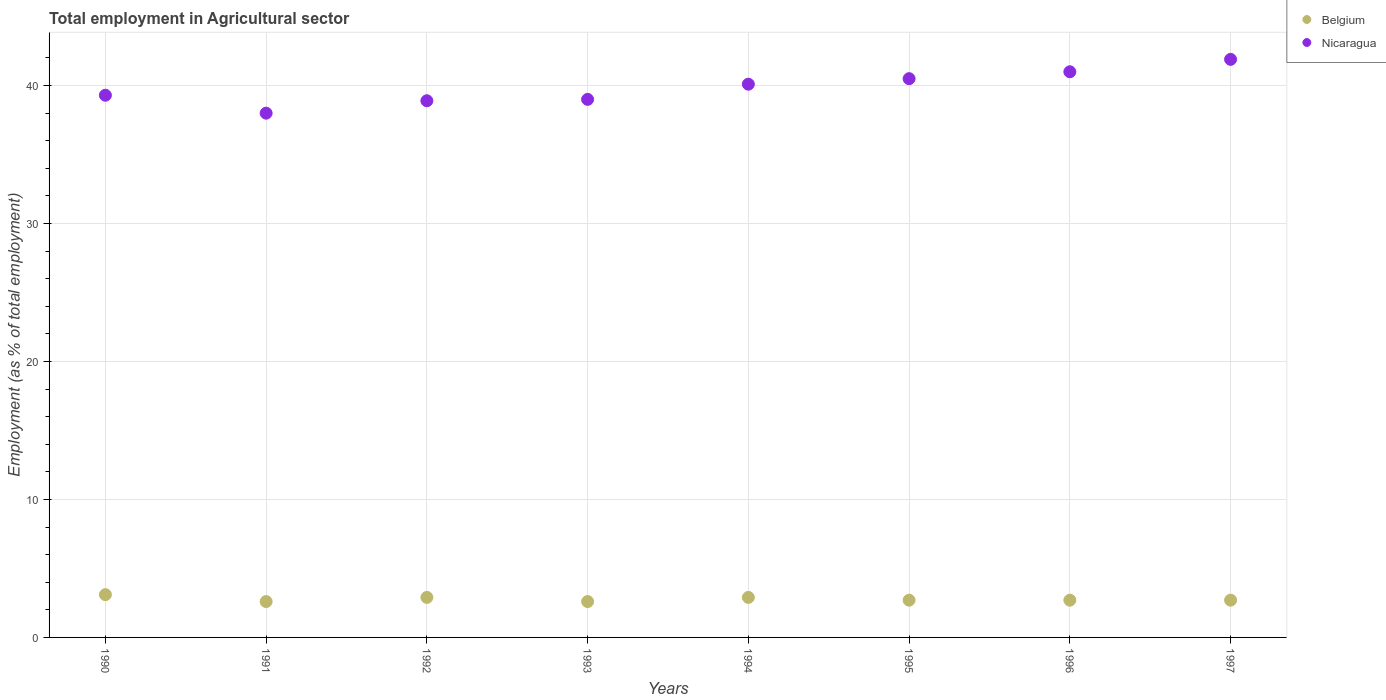How many different coloured dotlines are there?
Offer a terse response. 2. What is the employment in agricultural sector in Nicaragua in 1991?
Offer a very short reply. 38. Across all years, what is the maximum employment in agricultural sector in Nicaragua?
Offer a terse response. 41.9. Across all years, what is the minimum employment in agricultural sector in Belgium?
Ensure brevity in your answer.  2.6. What is the total employment in agricultural sector in Nicaragua in the graph?
Offer a very short reply. 318.7. What is the difference between the employment in agricultural sector in Nicaragua in 1990 and that in 1997?
Provide a short and direct response. -2.6. What is the difference between the employment in agricultural sector in Belgium in 1991 and the employment in agricultural sector in Nicaragua in 1995?
Provide a short and direct response. -37.9. What is the average employment in agricultural sector in Nicaragua per year?
Give a very brief answer. 39.84. In the year 1995, what is the difference between the employment in agricultural sector in Nicaragua and employment in agricultural sector in Belgium?
Make the answer very short. 37.8. In how many years, is the employment in agricultural sector in Nicaragua greater than 24 %?
Your response must be concise. 8. What is the difference between the highest and the second highest employment in agricultural sector in Nicaragua?
Offer a terse response. 0.9. What is the difference between the highest and the lowest employment in agricultural sector in Nicaragua?
Your answer should be compact. 3.9. In how many years, is the employment in agricultural sector in Belgium greater than the average employment in agricultural sector in Belgium taken over all years?
Your answer should be very brief. 3. Does the employment in agricultural sector in Belgium monotonically increase over the years?
Make the answer very short. No. Is the employment in agricultural sector in Belgium strictly less than the employment in agricultural sector in Nicaragua over the years?
Your answer should be very brief. Yes. How many years are there in the graph?
Provide a succinct answer. 8. What is the difference between two consecutive major ticks on the Y-axis?
Keep it short and to the point. 10. Where does the legend appear in the graph?
Offer a terse response. Top right. How many legend labels are there?
Your response must be concise. 2. How are the legend labels stacked?
Make the answer very short. Vertical. What is the title of the graph?
Keep it short and to the point. Total employment in Agricultural sector. Does "East Asia (all income levels)" appear as one of the legend labels in the graph?
Ensure brevity in your answer.  No. What is the label or title of the X-axis?
Provide a succinct answer. Years. What is the label or title of the Y-axis?
Make the answer very short. Employment (as % of total employment). What is the Employment (as % of total employment) in Belgium in 1990?
Offer a terse response. 3.1. What is the Employment (as % of total employment) in Nicaragua in 1990?
Your answer should be compact. 39.3. What is the Employment (as % of total employment) of Belgium in 1991?
Give a very brief answer. 2.6. What is the Employment (as % of total employment) of Belgium in 1992?
Offer a terse response. 2.9. What is the Employment (as % of total employment) in Nicaragua in 1992?
Give a very brief answer. 38.9. What is the Employment (as % of total employment) of Belgium in 1993?
Offer a terse response. 2.6. What is the Employment (as % of total employment) of Nicaragua in 1993?
Your answer should be very brief. 39. What is the Employment (as % of total employment) in Belgium in 1994?
Your answer should be compact. 2.9. What is the Employment (as % of total employment) of Nicaragua in 1994?
Offer a very short reply. 40.1. What is the Employment (as % of total employment) of Belgium in 1995?
Your answer should be very brief. 2.7. What is the Employment (as % of total employment) in Nicaragua in 1995?
Your answer should be very brief. 40.5. What is the Employment (as % of total employment) of Belgium in 1996?
Ensure brevity in your answer.  2.7. What is the Employment (as % of total employment) of Nicaragua in 1996?
Your answer should be compact. 41. What is the Employment (as % of total employment) of Belgium in 1997?
Make the answer very short. 2.7. What is the Employment (as % of total employment) of Nicaragua in 1997?
Offer a terse response. 41.9. Across all years, what is the maximum Employment (as % of total employment) in Belgium?
Provide a succinct answer. 3.1. Across all years, what is the maximum Employment (as % of total employment) of Nicaragua?
Provide a succinct answer. 41.9. Across all years, what is the minimum Employment (as % of total employment) in Belgium?
Keep it short and to the point. 2.6. Across all years, what is the minimum Employment (as % of total employment) in Nicaragua?
Give a very brief answer. 38. What is the total Employment (as % of total employment) in Belgium in the graph?
Offer a very short reply. 22.2. What is the total Employment (as % of total employment) in Nicaragua in the graph?
Make the answer very short. 318.7. What is the difference between the Employment (as % of total employment) of Belgium in 1990 and that in 1991?
Your response must be concise. 0.5. What is the difference between the Employment (as % of total employment) in Nicaragua in 1990 and that in 1992?
Your answer should be very brief. 0.4. What is the difference between the Employment (as % of total employment) of Belgium in 1990 and that in 1993?
Ensure brevity in your answer.  0.5. What is the difference between the Employment (as % of total employment) of Belgium in 1990 and that in 1996?
Your answer should be very brief. 0.4. What is the difference between the Employment (as % of total employment) of Belgium in 1990 and that in 1997?
Your response must be concise. 0.4. What is the difference between the Employment (as % of total employment) in Nicaragua in 1990 and that in 1997?
Offer a terse response. -2.6. What is the difference between the Employment (as % of total employment) of Belgium in 1991 and that in 1993?
Provide a short and direct response. 0. What is the difference between the Employment (as % of total employment) of Nicaragua in 1991 and that in 1993?
Your answer should be very brief. -1. What is the difference between the Employment (as % of total employment) of Belgium in 1991 and that in 1995?
Make the answer very short. -0.1. What is the difference between the Employment (as % of total employment) of Nicaragua in 1991 and that in 1995?
Your answer should be very brief. -2.5. What is the difference between the Employment (as % of total employment) in Belgium in 1991 and that in 1997?
Your answer should be compact. -0.1. What is the difference between the Employment (as % of total employment) of Nicaragua in 1992 and that in 1993?
Make the answer very short. -0.1. What is the difference between the Employment (as % of total employment) in Nicaragua in 1992 and that in 1994?
Provide a succinct answer. -1.2. What is the difference between the Employment (as % of total employment) in Belgium in 1992 and that in 1995?
Offer a very short reply. 0.2. What is the difference between the Employment (as % of total employment) in Nicaragua in 1992 and that in 1995?
Offer a terse response. -1.6. What is the difference between the Employment (as % of total employment) in Nicaragua in 1992 and that in 1997?
Offer a terse response. -3. What is the difference between the Employment (as % of total employment) of Nicaragua in 1993 and that in 1994?
Offer a very short reply. -1.1. What is the difference between the Employment (as % of total employment) in Nicaragua in 1993 and that in 1995?
Provide a short and direct response. -1.5. What is the difference between the Employment (as % of total employment) in Belgium in 1993 and that in 1996?
Ensure brevity in your answer.  -0.1. What is the difference between the Employment (as % of total employment) of Nicaragua in 1993 and that in 1996?
Make the answer very short. -2. What is the difference between the Employment (as % of total employment) of Belgium in 1993 and that in 1997?
Your response must be concise. -0.1. What is the difference between the Employment (as % of total employment) in Nicaragua in 1993 and that in 1997?
Ensure brevity in your answer.  -2.9. What is the difference between the Employment (as % of total employment) of Nicaragua in 1994 and that in 1996?
Ensure brevity in your answer.  -0.9. What is the difference between the Employment (as % of total employment) in Nicaragua in 1994 and that in 1997?
Make the answer very short. -1.8. What is the difference between the Employment (as % of total employment) in Nicaragua in 1995 and that in 1996?
Your answer should be very brief. -0.5. What is the difference between the Employment (as % of total employment) in Belgium in 1995 and that in 1997?
Provide a short and direct response. 0. What is the difference between the Employment (as % of total employment) of Nicaragua in 1995 and that in 1997?
Offer a very short reply. -1.4. What is the difference between the Employment (as % of total employment) of Belgium in 1990 and the Employment (as % of total employment) of Nicaragua in 1991?
Provide a short and direct response. -34.9. What is the difference between the Employment (as % of total employment) in Belgium in 1990 and the Employment (as % of total employment) in Nicaragua in 1992?
Your answer should be compact. -35.8. What is the difference between the Employment (as % of total employment) of Belgium in 1990 and the Employment (as % of total employment) of Nicaragua in 1993?
Offer a terse response. -35.9. What is the difference between the Employment (as % of total employment) in Belgium in 1990 and the Employment (as % of total employment) in Nicaragua in 1994?
Your response must be concise. -37. What is the difference between the Employment (as % of total employment) of Belgium in 1990 and the Employment (as % of total employment) of Nicaragua in 1995?
Ensure brevity in your answer.  -37.4. What is the difference between the Employment (as % of total employment) in Belgium in 1990 and the Employment (as % of total employment) in Nicaragua in 1996?
Your answer should be compact. -37.9. What is the difference between the Employment (as % of total employment) of Belgium in 1990 and the Employment (as % of total employment) of Nicaragua in 1997?
Provide a succinct answer. -38.8. What is the difference between the Employment (as % of total employment) of Belgium in 1991 and the Employment (as % of total employment) of Nicaragua in 1992?
Make the answer very short. -36.3. What is the difference between the Employment (as % of total employment) of Belgium in 1991 and the Employment (as % of total employment) of Nicaragua in 1993?
Provide a short and direct response. -36.4. What is the difference between the Employment (as % of total employment) of Belgium in 1991 and the Employment (as % of total employment) of Nicaragua in 1994?
Your response must be concise. -37.5. What is the difference between the Employment (as % of total employment) of Belgium in 1991 and the Employment (as % of total employment) of Nicaragua in 1995?
Offer a very short reply. -37.9. What is the difference between the Employment (as % of total employment) in Belgium in 1991 and the Employment (as % of total employment) in Nicaragua in 1996?
Your response must be concise. -38.4. What is the difference between the Employment (as % of total employment) of Belgium in 1991 and the Employment (as % of total employment) of Nicaragua in 1997?
Your answer should be compact. -39.3. What is the difference between the Employment (as % of total employment) of Belgium in 1992 and the Employment (as % of total employment) of Nicaragua in 1993?
Provide a short and direct response. -36.1. What is the difference between the Employment (as % of total employment) of Belgium in 1992 and the Employment (as % of total employment) of Nicaragua in 1994?
Give a very brief answer. -37.2. What is the difference between the Employment (as % of total employment) in Belgium in 1992 and the Employment (as % of total employment) in Nicaragua in 1995?
Your answer should be very brief. -37.6. What is the difference between the Employment (as % of total employment) in Belgium in 1992 and the Employment (as % of total employment) in Nicaragua in 1996?
Provide a short and direct response. -38.1. What is the difference between the Employment (as % of total employment) of Belgium in 1992 and the Employment (as % of total employment) of Nicaragua in 1997?
Your response must be concise. -39. What is the difference between the Employment (as % of total employment) in Belgium in 1993 and the Employment (as % of total employment) in Nicaragua in 1994?
Ensure brevity in your answer.  -37.5. What is the difference between the Employment (as % of total employment) of Belgium in 1993 and the Employment (as % of total employment) of Nicaragua in 1995?
Your answer should be compact. -37.9. What is the difference between the Employment (as % of total employment) of Belgium in 1993 and the Employment (as % of total employment) of Nicaragua in 1996?
Offer a very short reply. -38.4. What is the difference between the Employment (as % of total employment) of Belgium in 1993 and the Employment (as % of total employment) of Nicaragua in 1997?
Give a very brief answer. -39.3. What is the difference between the Employment (as % of total employment) in Belgium in 1994 and the Employment (as % of total employment) in Nicaragua in 1995?
Your answer should be compact. -37.6. What is the difference between the Employment (as % of total employment) in Belgium in 1994 and the Employment (as % of total employment) in Nicaragua in 1996?
Offer a terse response. -38.1. What is the difference between the Employment (as % of total employment) of Belgium in 1994 and the Employment (as % of total employment) of Nicaragua in 1997?
Provide a succinct answer. -39. What is the difference between the Employment (as % of total employment) in Belgium in 1995 and the Employment (as % of total employment) in Nicaragua in 1996?
Your response must be concise. -38.3. What is the difference between the Employment (as % of total employment) of Belgium in 1995 and the Employment (as % of total employment) of Nicaragua in 1997?
Provide a succinct answer. -39.2. What is the difference between the Employment (as % of total employment) in Belgium in 1996 and the Employment (as % of total employment) in Nicaragua in 1997?
Your answer should be compact. -39.2. What is the average Employment (as % of total employment) in Belgium per year?
Provide a succinct answer. 2.77. What is the average Employment (as % of total employment) of Nicaragua per year?
Offer a terse response. 39.84. In the year 1990, what is the difference between the Employment (as % of total employment) of Belgium and Employment (as % of total employment) of Nicaragua?
Offer a terse response. -36.2. In the year 1991, what is the difference between the Employment (as % of total employment) of Belgium and Employment (as % of total employment) of Nicaragua?
Provide a short and direct response. -35.4. In the year 1992, what is the difference between the Employment (as % of total employment) of Belgium and Employment (as % of total employment) of Nicaragua?
Give a very brief answer. -36. In the year 1993, what is the difference between the Employment (as % of total employment) of Belgium and Employment (as % of total employment) of Nicaragua?
Ensure brevity in your answer.  -36.4. In the year 1994, what is the difference between the Employment (as % of total employment) in Belgium and Employment (as % of total employment) in Nicaragua?
Provide a succinct answer. -37.2. In the year 1995, what is the difference between the Employment (as % of total employment) of Belgium and Employment (as % of total employment) of Nicaragua?
Your answer should be very brief. -37.8. In the year 1996, what is the difference between the Employment (as % of total employment) in Belgium and Employment (as % of total employment) in Nicaragua?
Your answer should be very brief. -38.3. In the year 1997, what is the difference between the Employment (as % of total employment) in Belgium and Employment (as % of total employment) in Nicaragua?
Your response must be concise. -39.2. What is the ratio of the Employment (as % of total employment) of Belgium in 1990 to that in 1991?
Keep it short and to the point. 1.19. What is the ratio of the Employment (as % of total employment) of Nicaragua in 1990 to that in 1991?
Offer a terse response. 1.03. What is the ratio of the Employment (as % of total employment) of Belgium in 1990 to that in 1992?
Make the answer very short. 1.07. What is the ratio of the Employment (as % of total employment) in Nicaragua in 1990 to that in 1992?
Ensure brevity in your answer.  1.01. What is the ratio of the Employment (as % of total employment) of Belgium in 1990 to that in 1993?
Your response must be concise. 1.19. What is the ratio of the Employment (as % of total employment) of Nicaragua in 1990 to that in 1993?
Offer a terse response. 1.01. What is the ratio of the Employment (as % of total employment) in Belgium in 1990 to that in 1994?
Offer a very short reply. 1.07. What is the ratio of the Employment (as % of total employment) of Belgium in 1990 to that in 1995?
Provide a short and direct response. 1.15. What is the ratio of the Employment (as % of total employment) of Nicaragua in 1990 to that in 1995?
Your answer should be compact. 0.97. What is the ratio of the Employment (as % of total employment) of Belgium in 1990 to that in 1996?
Your answer should be very brief. 1.15. What is the ratio of the Employment (as % of total employment) of Nicaragua in 1990 to that in 1996?
Provide a short and direct response. 0.96. What is the ratio of the Employment (as % of total employment) in Belgium in 1990 to that in 1997?
Your answer should be compact. 1.15. What is the ratio of the Employment (as % of total employment) in Nicaragua in 1990 to that in 1997?
Give a very brief answer. 0.94. What is the ratio of the Employment (as % of total employment) in Belgium in 1991 to that in 1992?
Ensure brevity in your answer.  0.9. What is the ratio of the Employment (as % of total employment) of Nicaragua in 1991 to that in 1992?
Keep it short and to the point. 0.98. What is the ratio of the Employment (as % of total employment) of Nicaragua in 1991 to that in 1993?
Your answer should be very brief. 0.97. What is the ratio of the Employment (as % of total employment) of Belgium in 1991 to that in 1994?
Offer a very short reply. 0.9. What is the ratio of the Employment (as % of total employment) in Nicaragua in 1991 to that in 1994?
Provide a short and direct response. 0.95. What is the ratio of the Employment (as % of total employment) of Nicaragua in 1991 to that in 1995?
Offer a very short reply. 0.94. What is the ratio of the Employment (as % of total employment) of Nicaragua in 1991 to that in 1996?
Provide a succinct answer. 0.93. What is the ratio of the Employment (as % of total employment) of Belgium in 1991 to that in 1997?
Your answer should be very brief. 0.96. What is the ratio of the Employment (as % of total employment) of Nicaragua in 1991 to that in 1997?
Keep it short and to the point. 0.91. What is the ratio of the Employment (as % of total employment) of Belgium in 1992 to that in 1993?
Give a very brief answer. 1.12. What is the ratio of the Employment (as % of total employment) of Belgium in 1992 to that in 1994?
Your answer should be compact. 1. What is the ratio of the Employment (as % of total employment) in Nicaragua in 1992 to that in 1994?
Your answer should be compact. 0.97. What is the ratio of the Employment (as % of total employment) of Belgium in 1992 to that in 1995?
Your response must be concise. 1.07. What is the ratio of the Employment (as % of total employment) in Nicaragua in 1992 to that in 1995?
Your answer should be compact. 0.96. What is the ratio of the Employment (as % of total employment) of Belgium in 1992 to that in 1996?
Offer a terse response. 1.07. What is the ratio of the Employment (as % of total employment) of Nicaragua in 1992 to that in 1996?
Give a very brief answer. 0.95. What is the ratio of the Employment (as % of total employment) in Belgium in 1992 to that in 1997?
Keep it short and to the point. 1.07. What is the ratio of the Employment (as % of total employment) of Nicaragua in 1992 to that in 1997?
Give a very brief answer. 0.93. What is the ratio of the Employment (as % of total employment) of Belgium in 1993 to that in 1994?
Provide a short and direct response. 0.9. What is the ratio of the Employment (as % of total employment) of Nicaragua in 1993 to that in 1994?
Ensure brevity in your answer.  0.97. What is the ratio of the Employment (as % of total employment) in Nicaragua in 1993 to that in 1995?
Keep it short and to the point. 0.96. What is the ratio of the Employment (as % of total employment) in Belgium in 1993 to that in 1996?
Offer a very short reply. 0.96. What is the ratio of the Employment (as % of total employment) in Nicaragua in 1993 to that in 1996?
Give a very brief answer. 0.95. What is the ratio of the Employment (as % of total employment) in Nicaragua in 1993 to that in 1997?
Make the answer very short. 0.93. What is the ratio of the Employment (as % of total employment) in Belgium in 1994 to that in 1995?
Provide a short and direct response. 1.07. What is the ratio of the Employment (as % of total employment) in Belgium in 1994 to that in 1996?
Make the answer very short. 1.07. What is the ratio of the Employment (as % of total employment) in Belgium in 1994 to that in 1997?
Keep it short and to the point. 1.07. What is the ratio of the Employment (as % of total employment) in Nicaragua in 1994 to that in 1997?
Offer a terse response. 0.96. What is the ratio of the Employment (as % of total employment) of Belgium in 1995 to that in 1996?
Make the answer very short. 1. What is the ratio of the Employment (as % of total employment) in Belgium in 1995 to that in 1997?
Give a very brief answer. 1. What is the ratio of the Employment (as % of total employment) of Nicaragua in 1995 to that in 1997?
Provide a succinct answer. 0.97. What is the ratio of the Employment (as % of total employment) in Belgium in 1996 to that in 1997?
Your answer should be compact. 1. What is the ratio of the Employment (as % of total employment) of Nicaragua in 1996 to that in 1997?
Make the answer very short. 0.98. What is the difference between the highest and the second highest Employment (as % of total employment) in Belgium?
Provide a succinct answer. 0.2. 